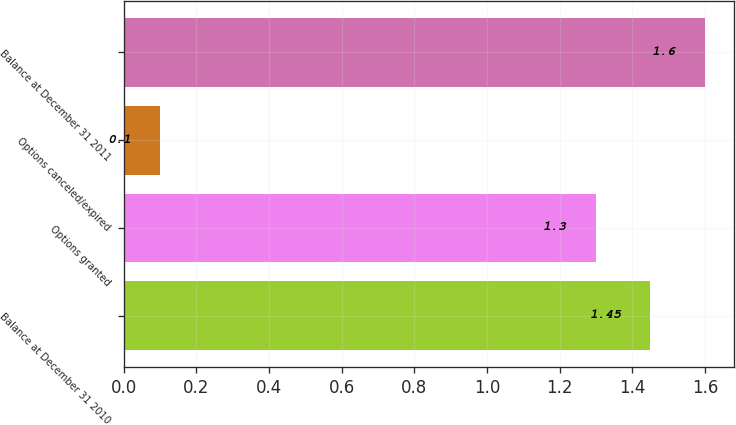Convert chart to OTSL. <chart><loc_0><loc_0><loc_500><loc_500><bar_chart><fcel>Balance at December 31 2010<fcel>Options granted<fcel>Options canceled/expired<fcel>Balance at December 31 2011<nl><fcel>1.45<fcel>1.3<fcel>0.1<fcel>1.6<nl></chart> 